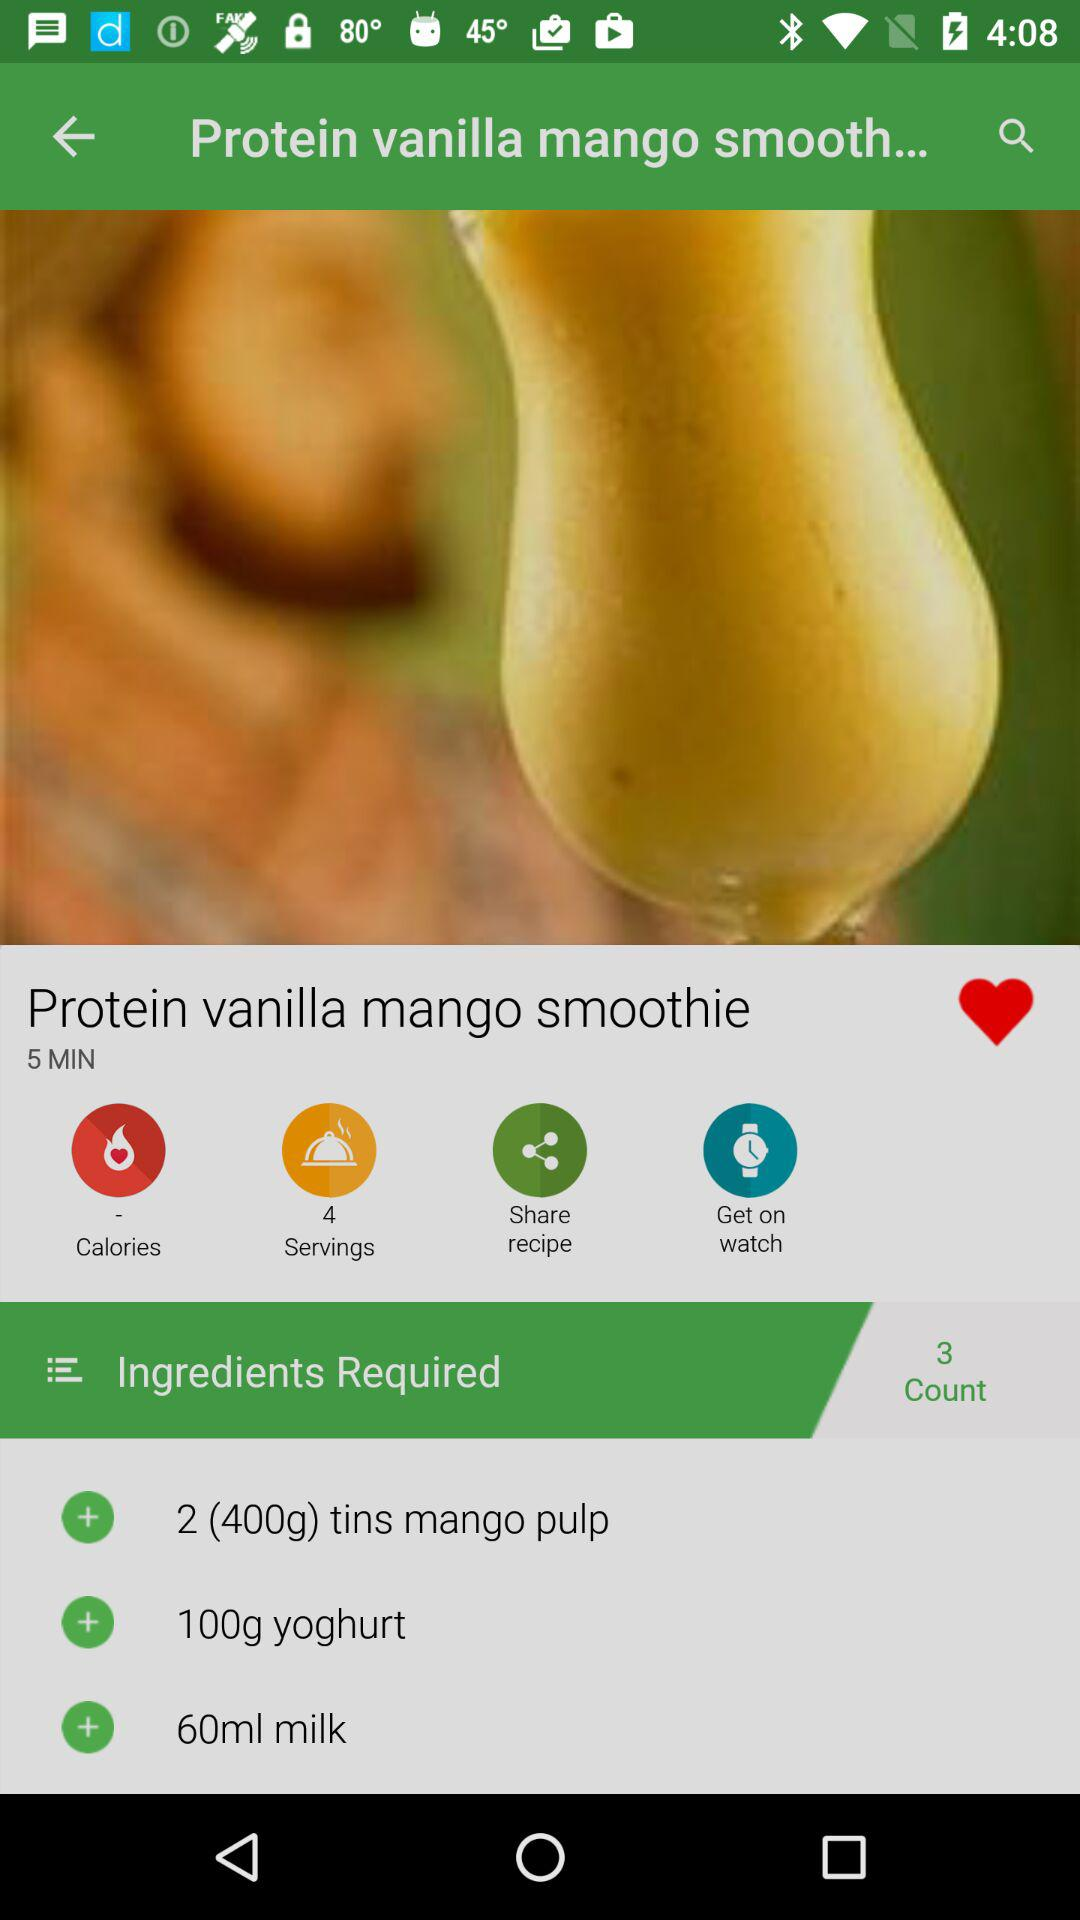How long does it take to make the smoothie? It takes 5 minutes to make the smoothie. 